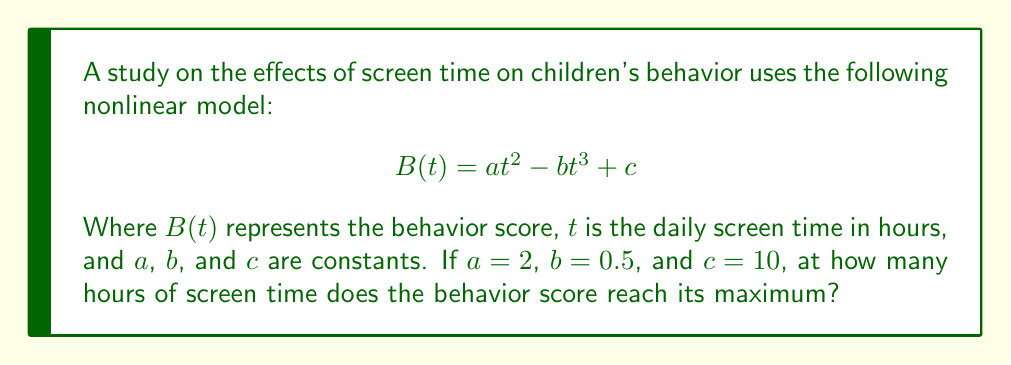Teach me how to tackle this problem. 1) The behavior score $B(t)$ is a function of screen time $t$. To find the maximum, we need to find where the derivative equals zero:

   $$\frac{dB}{dt} = 2at - 3bt^2$$

2) Substitute the given values $a=2$ and $b=0.5$:

   $$\frac{dB}{dt} = 4t - 1.5t^2$$

3) Set the derivative to zero and solve:

   $$4t - 1.5t^2 = 0$$
   $$t(4 - 1.5t) = 0$$

4) Solve the equation:
   
   $t = 0$ or $4 - 1.5t = 0$
   
   For the second part: $1.5t = 4$, so $t = \frac{4}{1.5} = \frac{8}{3} \approx 2.67$

5) The solution $t = 0$ gives a minimum, not a maximum. Therefore, the maximum occurs at $t = \frac{8}{3}$ hours.

6) To verify this is a maximum, we can check the second derivative:

   $$\frac{d^2B}{dt^2} = 4 - 3t$$

   At $t = \frac{8}{3}$, $\frac{d^2B}{dt^2} = 4 - 3(\frac{8}{3}) = -4 < 0$, confirming a maximum.
Answer: $\frac{8}{3}$ hours 